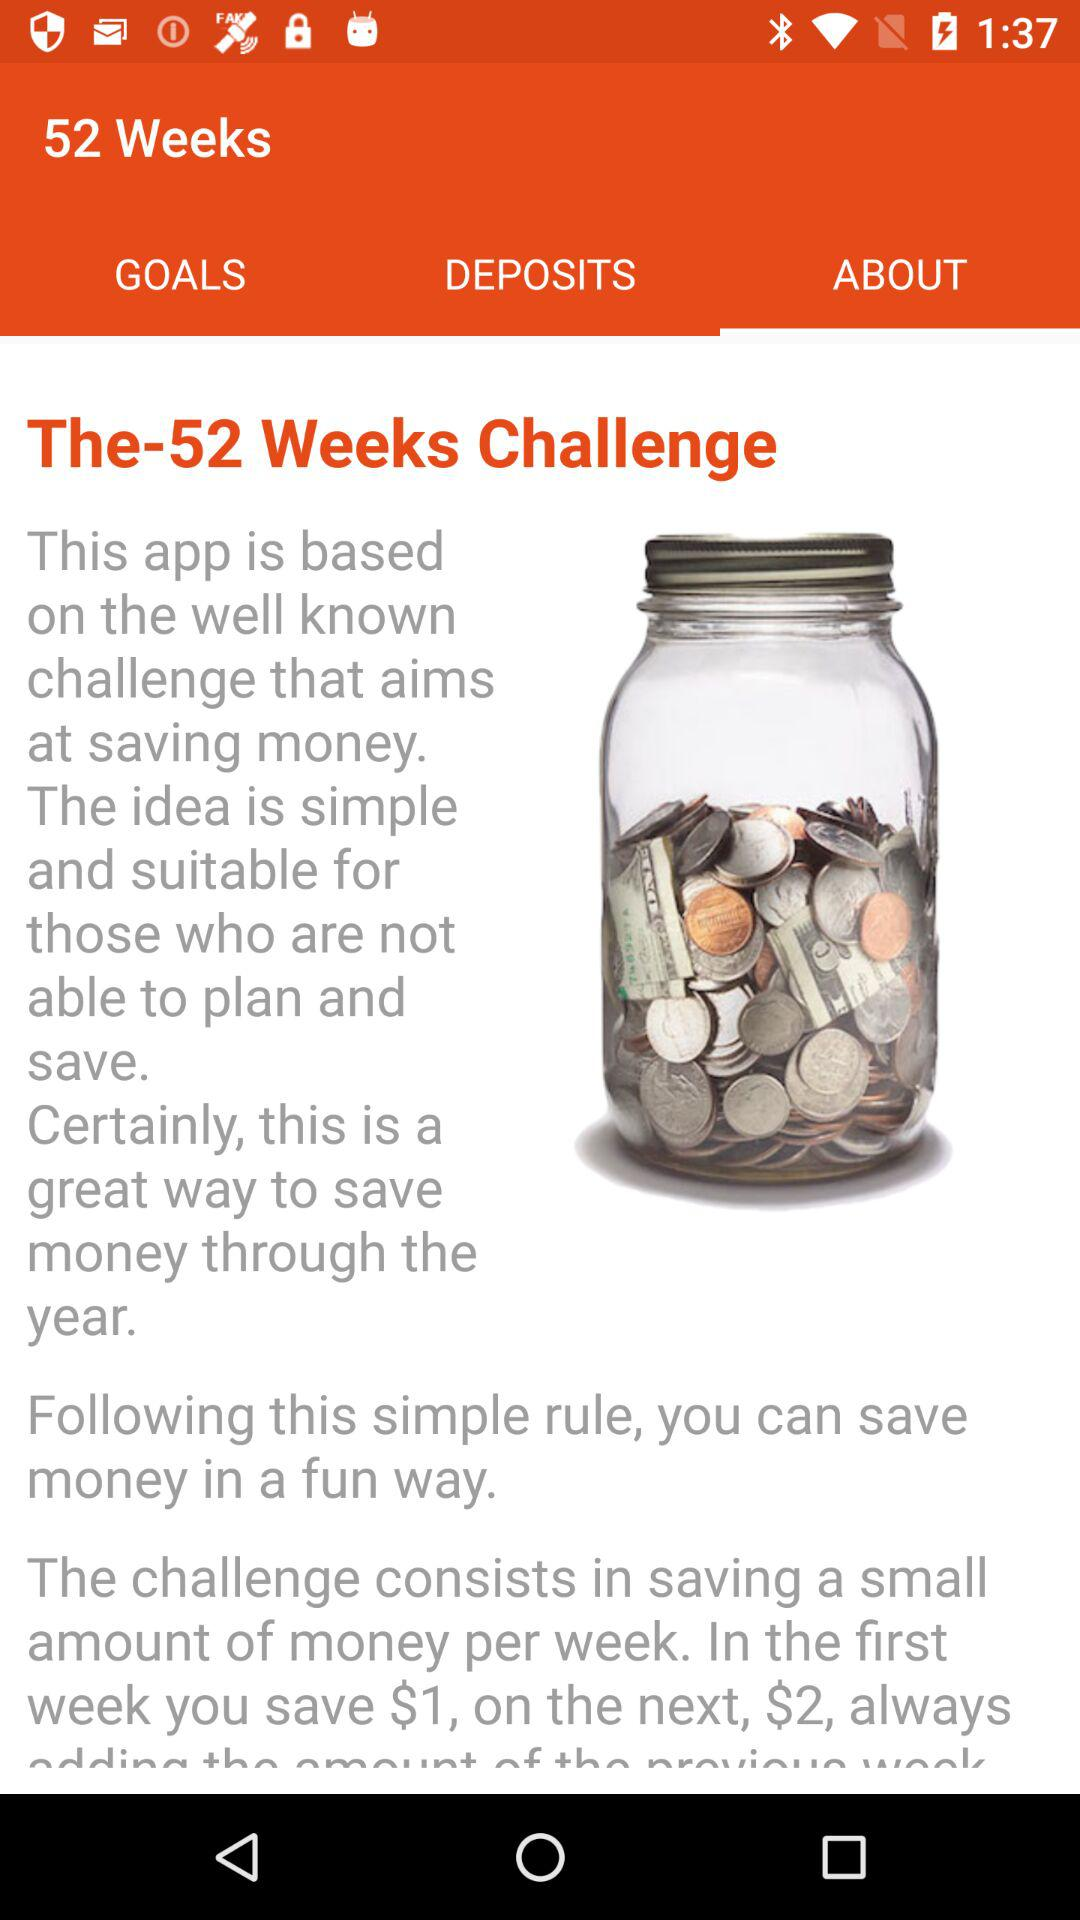What is the selected tab? The selected tab is "ABOUT". 